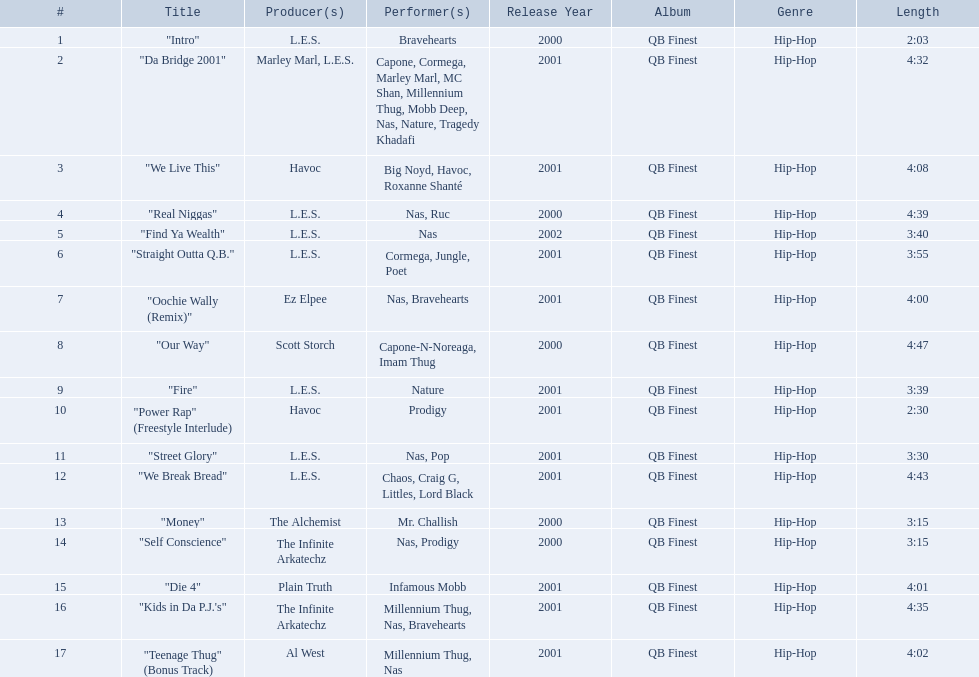How long is each song? 2:03, 4:32, 4:08, 4:39, 3:40, 3:55, 4:00, 4:47, 3:39, 2:30, 3:30, 4:43, 3:15, 3:15, 4:01, 4:35, 4:02. Of those, which length is the shortest? 2:03. 